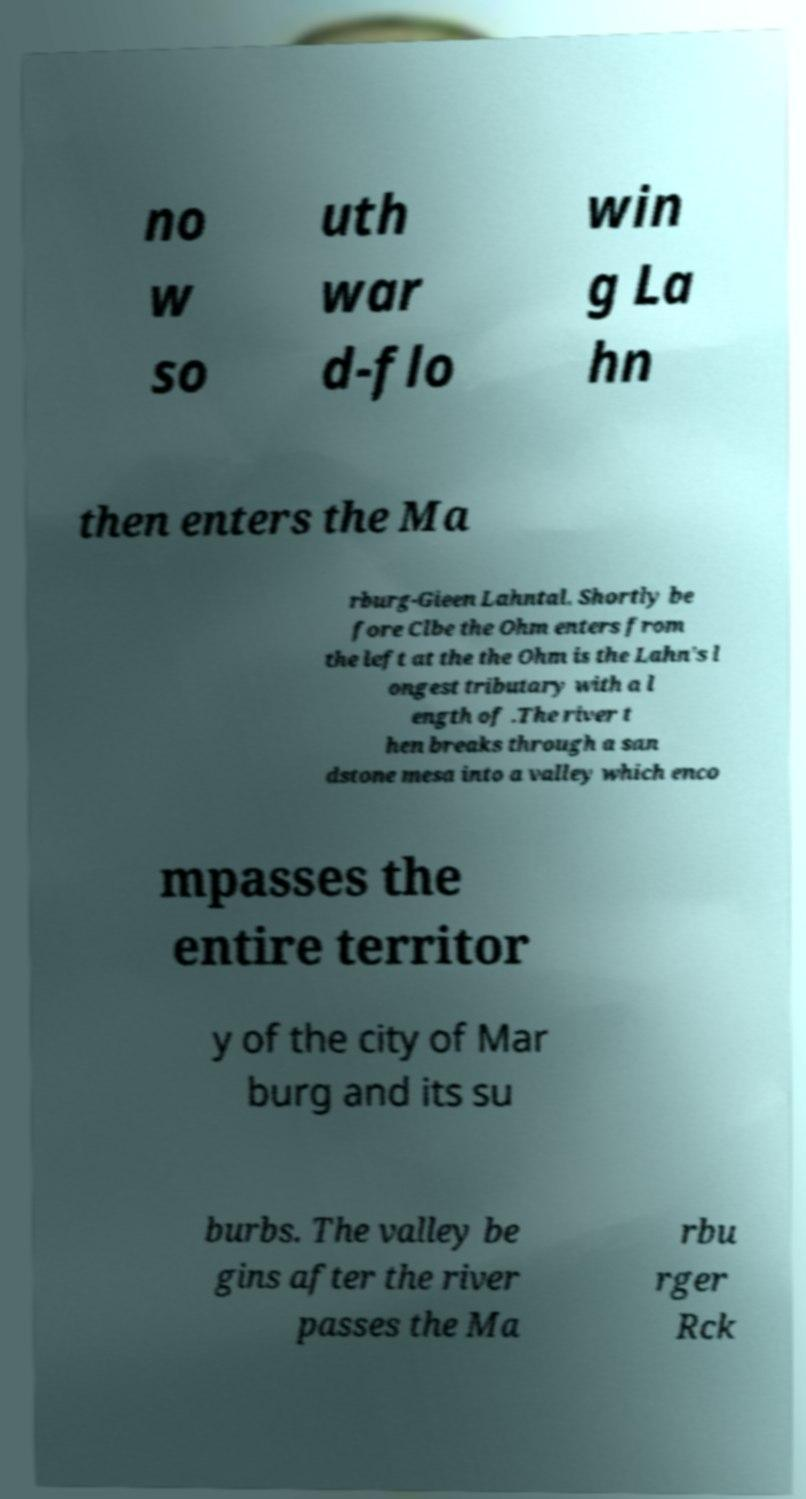Can you read and provide the text displayed in the image?This photo seems to have some interesting text. Can you extract and type it out for me? no w so uth war d-flo win g La hn then enters the Ma rburg-Gieen Lahntal. Shortly be fore Clbe the Ohm enters from the left at the the Ohm is the Lahn's l ongest tributary with a l ength of .The river t hen breaks through a san dstone mesa into a valley which enco mpasses the entire territor y of the city of Mar burg and its su burbs. The valley be gins after the river passes the Ma rbu rger Rck 